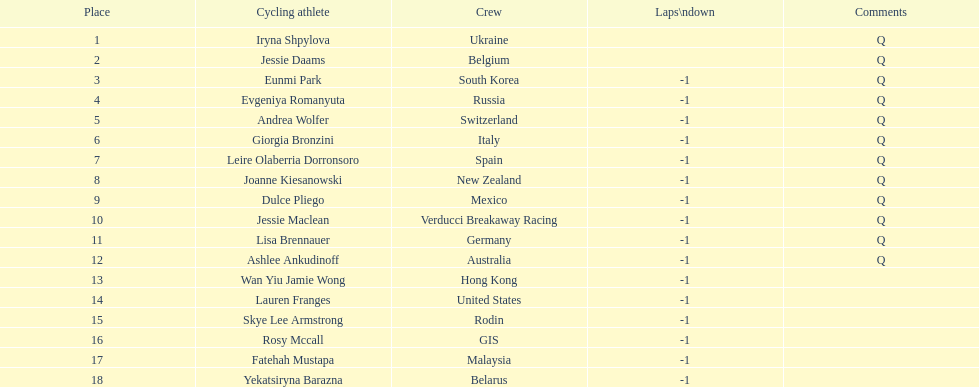Who was the first competitor to finish the race a lap behind? Eunmi Park. 